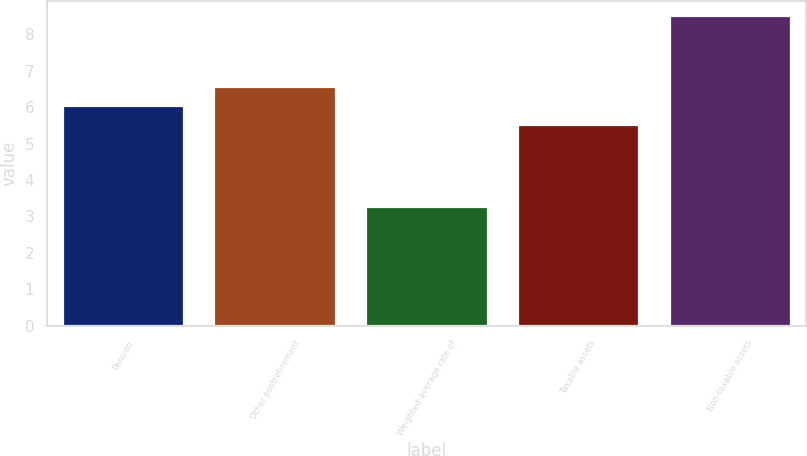Convert chart. <chart><loc_0><loc_0><loc_500><loc_500><bar_chart><fcel>Pension<fcel>Other postretirement<fcel>Weighted-average rate of<fcel>Taxable assets<fcel>Non-taxable assets<nl><fcel>6.03<fcel>6.56<fcel>3.25<fcel>5.5<fcel>8.5<nl></chart> 